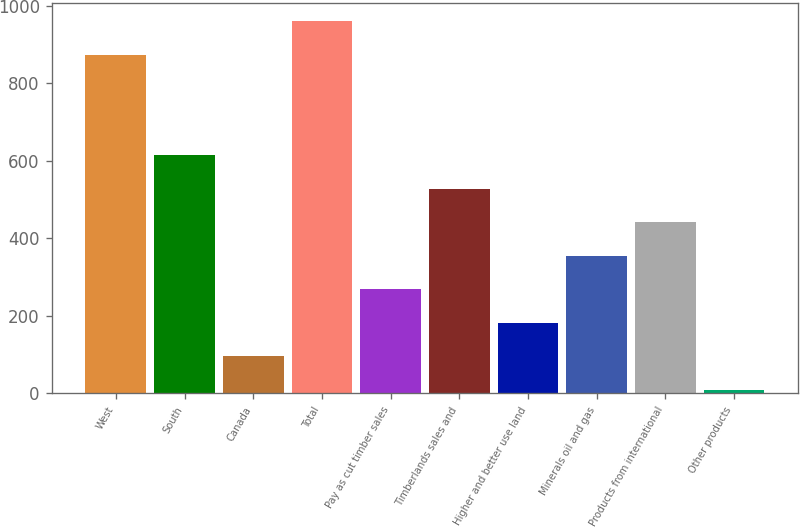<chart> <loc_0><loc_0><loc_500><loc_500><bar_chart><fcel>West<fcel>South<fcel>Canada<fcel>Total<fcel>Pay as cut timber sales<fcel>Timberlands sales and<fcel>Higher and better use land<fcel>Minerals oil and gas<fcel>Products from international<fcel>Other products<nl><fcel>874<fcel>614.5<fcel>95.5<fcel>960.5<fcel>268.5<fcel>528<fcel>182<fcel>355<fcel>441.5<fcel>9<nl></chart> 